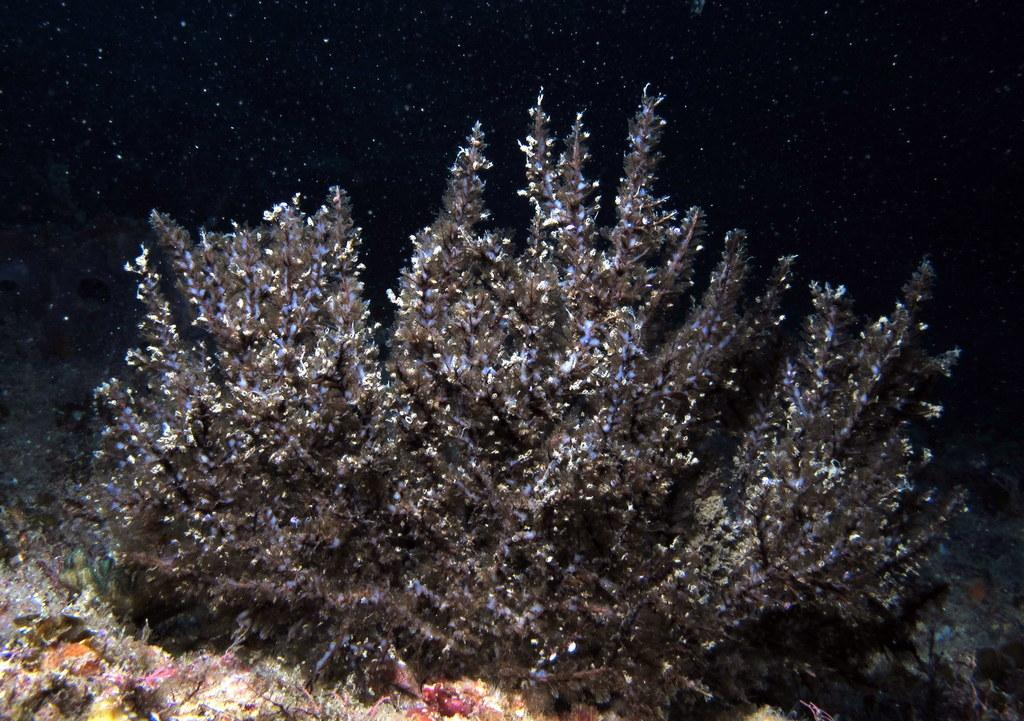What type of vegetation can be seen in the picture? There is a plant and grass in the picture. Can you describe the plant in the picture? Unfortunately, the facts provided do not give any details about the plant. What is the natural setting visible in the picture? The natural setting includes the plant and grass. How many sheep are visible in the picture? There are no sheep present in the picture; it only features a plant and grass. What type of office furniture can be seen in the picture? There is no office furniture present in the picture; it is a natural setting with a plant and grass. 